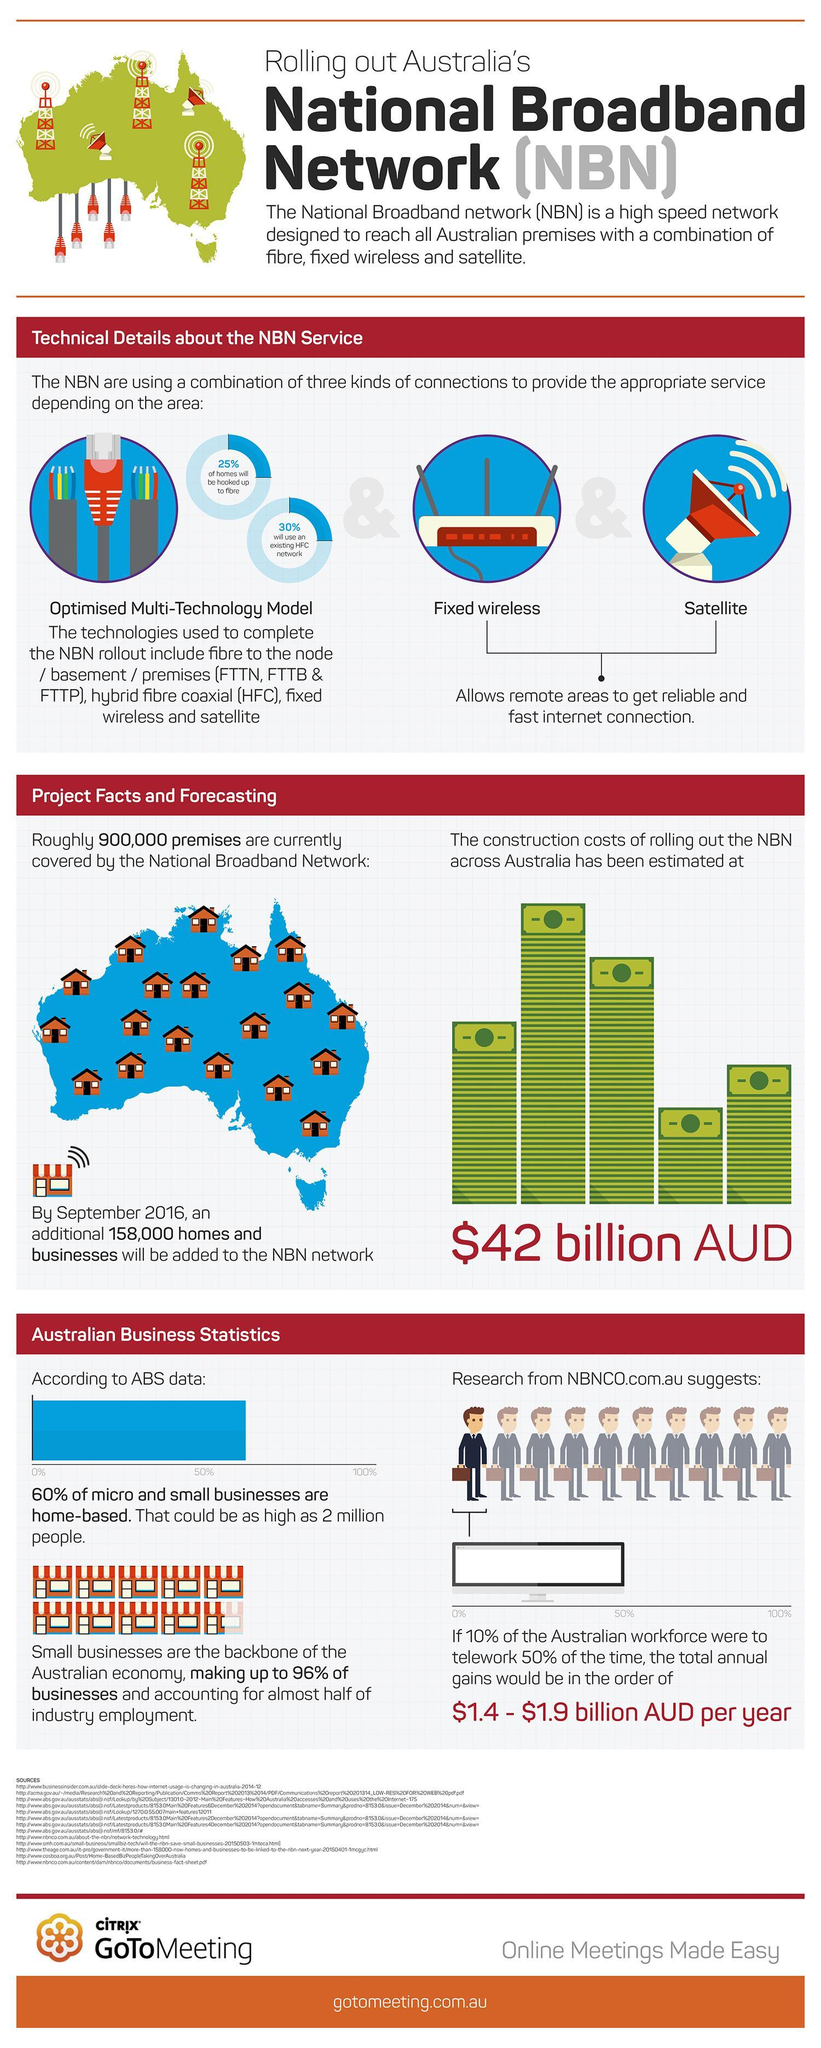What percentage of micro and small businesses are not home-based?
Answer the question with a short phrase. 40% What percentage of businesses are not small businesses in Australia? 4% Which factors affect the reliable and fast internet connections in remote areas? Fixed wireless, Satellite 